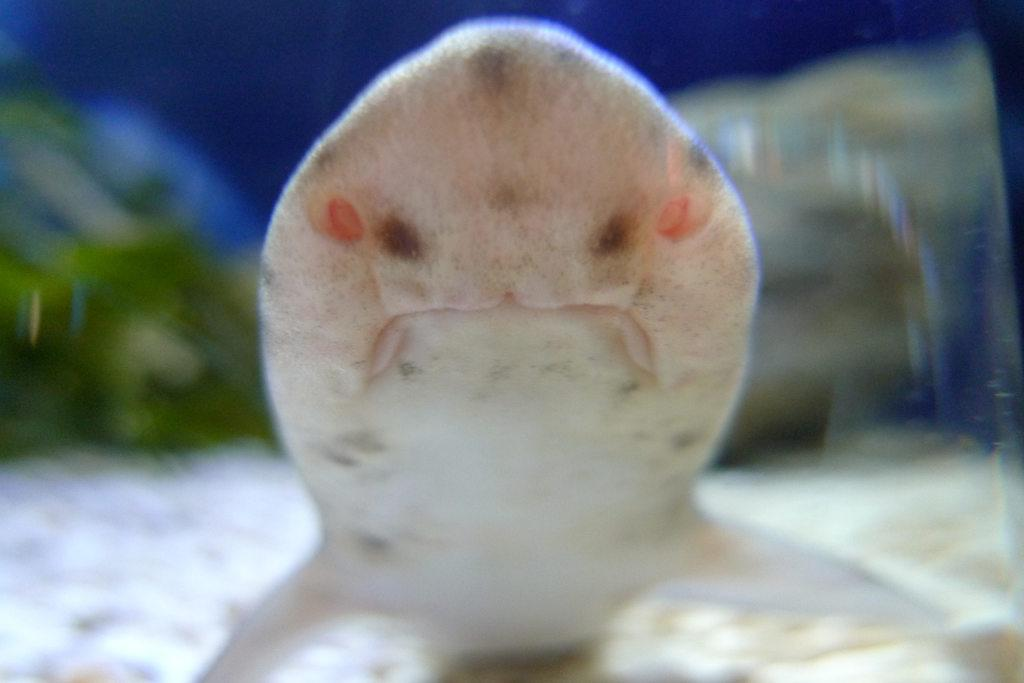What type of animals can be seen in the image? Fish can be seen in the water. Can you describe the background of the image? The background of the image is blurry. What historical event is depicted in the image? There is no historical event depicted in the image; it features fish in the water and a blurry background. What type of chain can be seen connecting the fish in the image? There is no chain present in the image; it only shows fish in the water. 